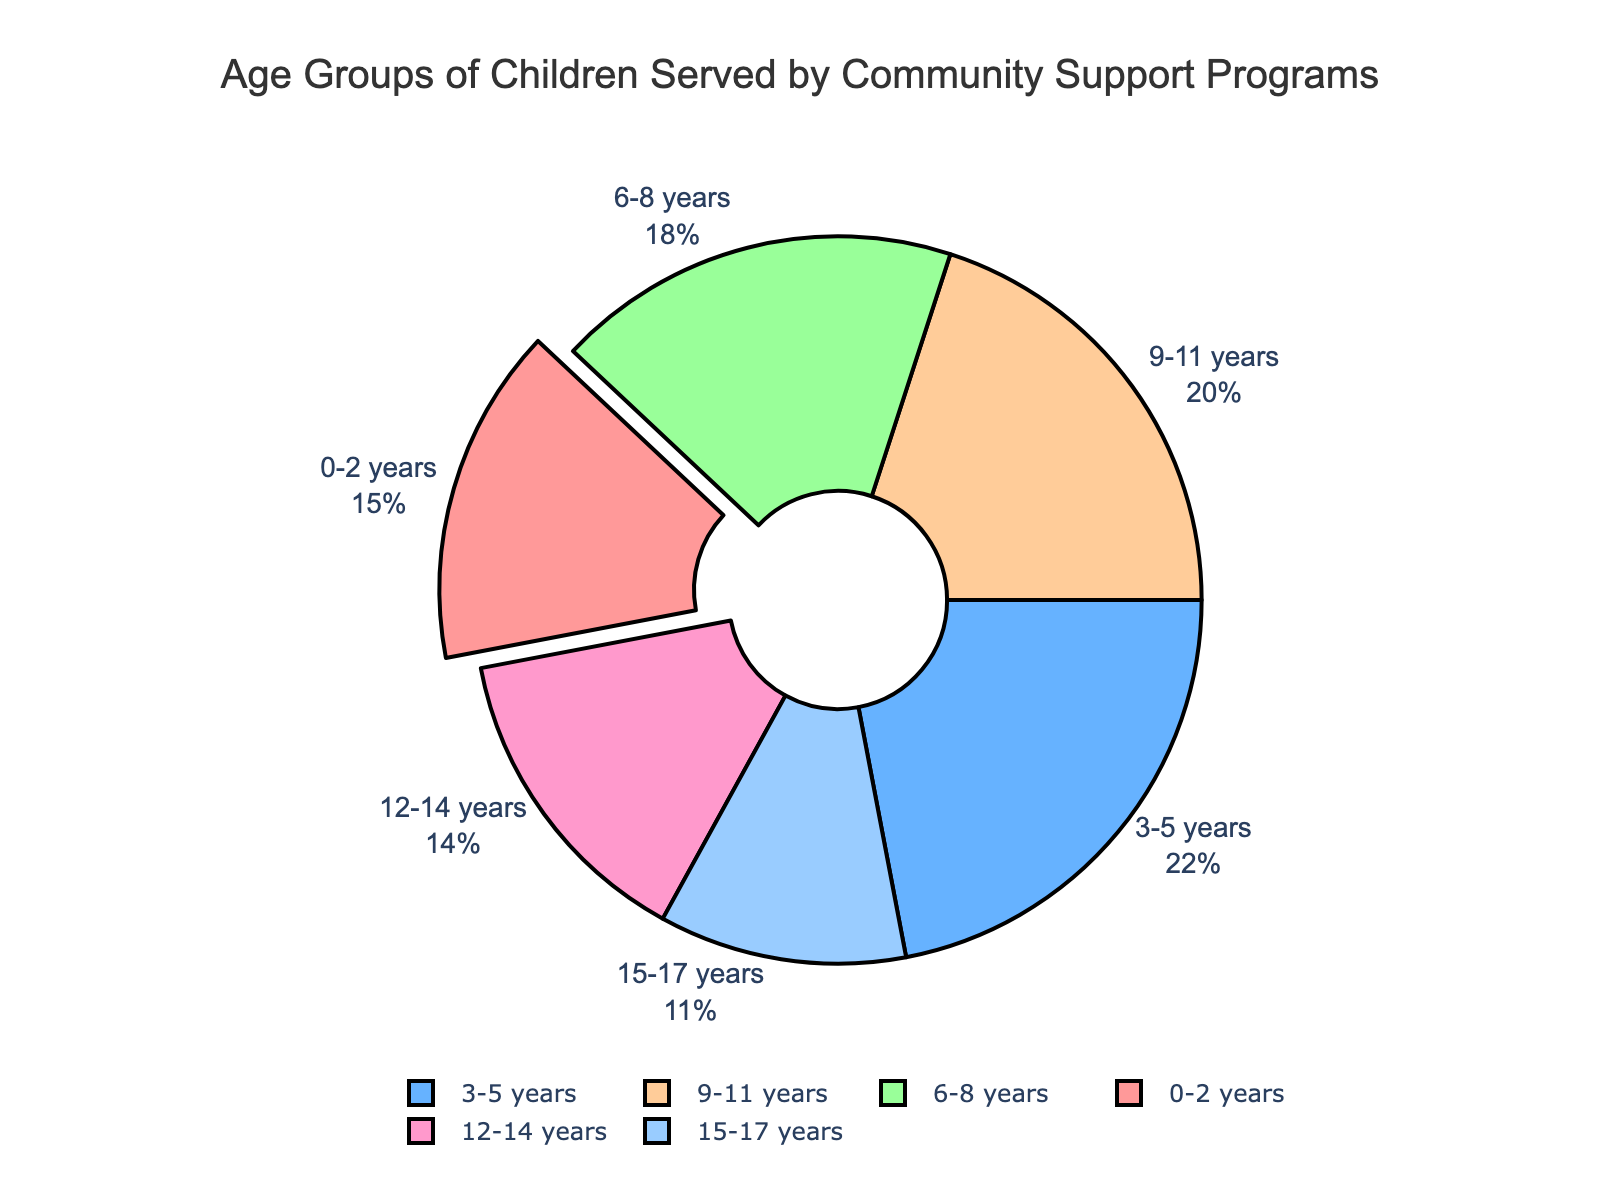What percentage of children served are in the 3-5 years age group? The pie chart shows the percentage values for each age group. Referring to the chart, the 3-5 years age group is labeled with a percentage of 22%.
Answer: 22% Which age group has the smallest percentage of children served? By looking at the pie chart, we see the age group with the smallest segment. The 15-17 years age group has the smallest segment with 11%.
Answer: 15-17 years How many age groups are represented in the pie chart? By counting the number of distinct segments or labels in the pie chart, we find that there are six age groups represented.
Answer: 6 What is the total percentage of children served in the age groups from 6 to 11 years? To find the total percentage for these age groups, we sum the individual percentages of 6-8 years (18%) and 9-11 years (20%). Total = 18% + 20% = 38%
Answer: 38% Which age group has a larger percentage of children served, 0-2 years or 12-14 years? The pie chart shows that the 0-2 years age group has 15%, whereas the 12-14 years age group has 14%. Therefore, 0-2 years has a larger percentage.
Answer: 0-2 years What is the difference in the percentage of children served between age groups 3-5 years and 15-17 years? Referring to the pie chart, 3-5 years has 22% and 15-17 years has 11%. The difference is 22% - 11% = 11%.
Answer: 11% Which age group has a larger slice than the age group 12-14 years but smaller than the age group 3-5 years? By comparing the sizes of the slices, the 9-11 years age group has 20% which is larger than 12-14 years (14%) and smaller than 3-5 years (22%).
Answer: 9-11 years What is the average percentage of children served in the age groups 0-2 years, 9-11 years, and 12-14 years? First, sum the percentages for these age groups: 15% (0-2) + 20% (9-11) + 14% (12-14) = 49%. Then, divide by the number of age groups, which is 3. Average = 49% / 3 ≈ 16.33%.
Answer: 16.33% Which color represents the age group with the highest percentage of children served? The pie chart assigns different colors to each age group. The largest segment is the 3-5 years age group with 22%. The color of this segment is identified by the visual inspection of the chart as blue.
Answer: Blue 